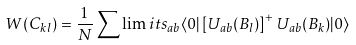<formula> <loc_0><loc_0><loc_500><loc_500>W ( C _ { k l } ) = \frac { 1 } { N } \sum \lim i t s _ { a b } \langle 0 | \left [ U _ { a b } ( B _ { l } ) \right ] ^ { + } U _ { a b } ( B _ { k } ) | 0 \rangle</formula> 